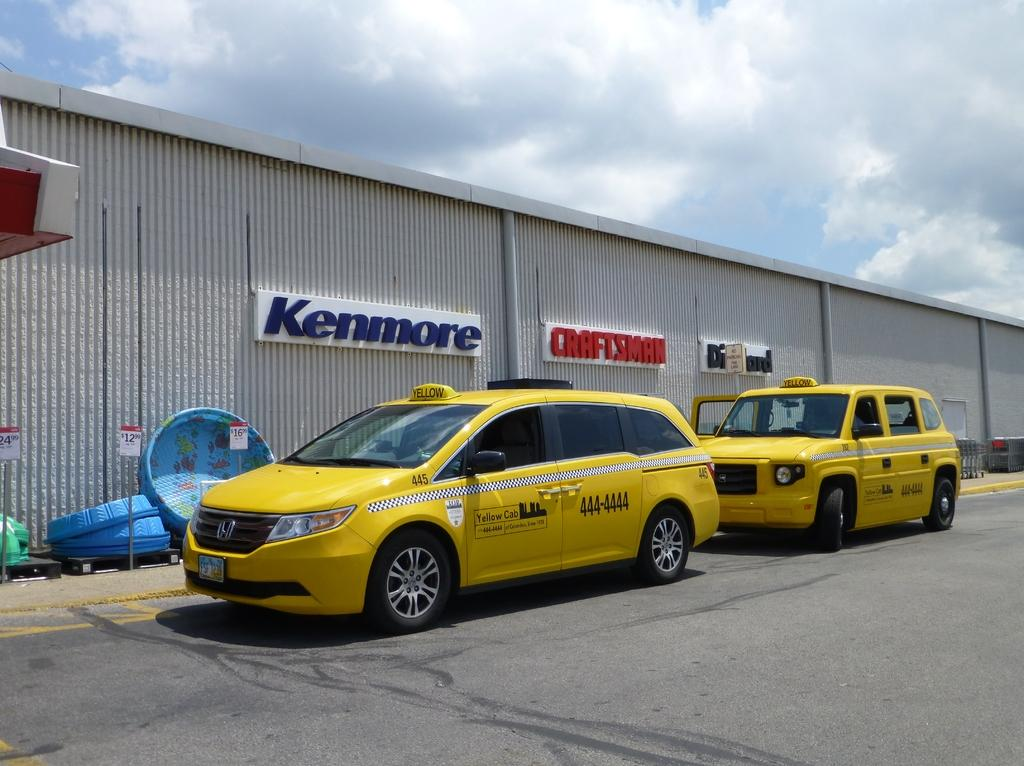<image>
Relay a brief, clear account of the picture shown. Two yellow vehicles, both in front of a background which reads Kenmore. 